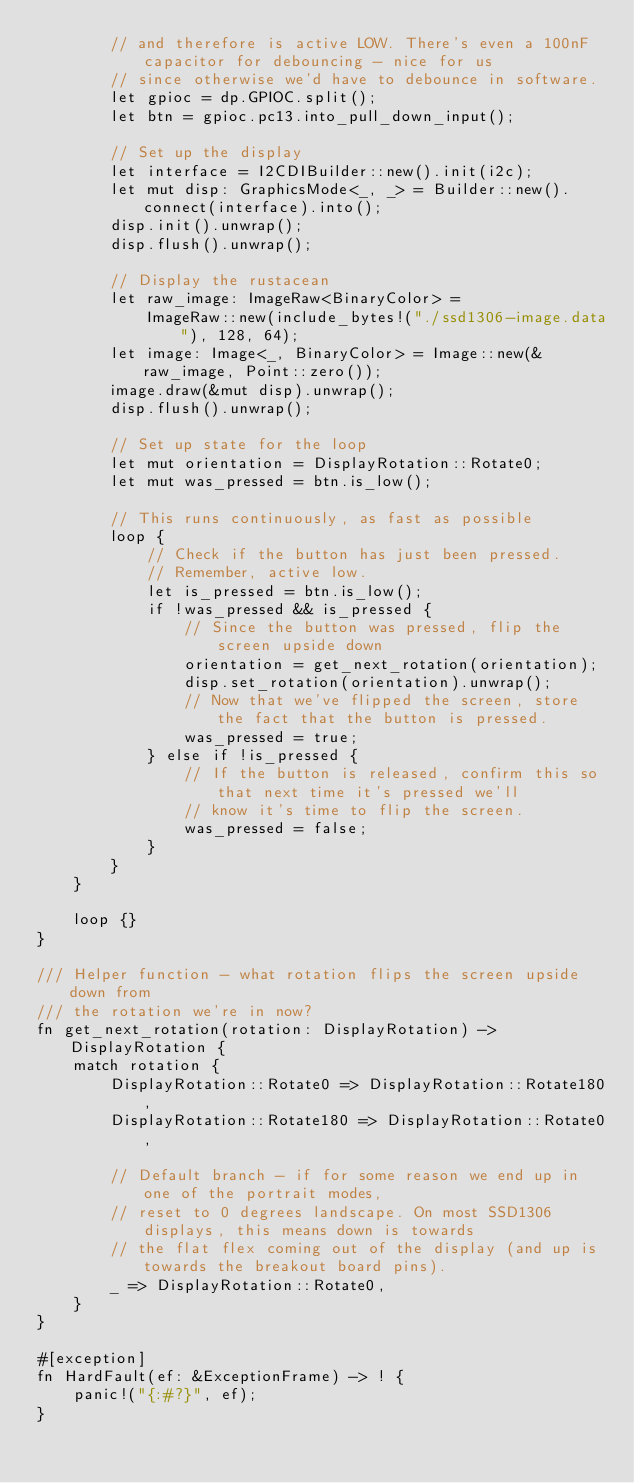<code> <loc_0><loc_0><loc_500><loc_500><_Rust_>        // and therefore is active LOW. There's even a 100nF capacitor for debouncing - nice for us
        // since otherwise we'd have to debounce in software.
        let gpioc = dp.GPIOC.split();
        let btn = gpioc.pc13.into_pull_down_input();

        // Set up the display
        let interface = I2CDIBuilder::new().init(i2c);
        let mut disp: GraphicsMode<_, _> = Builder::new().connect(interface).into();
        disp.init().unwrap();
        disp.flush().unwrap();

        // Display the rustacean
        let raw_image: ImageRaw<BinaryColor> =
            ImageRaw::new(include_bytes!("./ssd1306-image.data"), 128, 64);
        let image: Image<_, BinaryColor> = Image::new(&raw_image, Point::zero());
        image.draw(&mut disp).unwrap();
        disp.flush().unwrap();

        // Set up state for the loop
        let mut orientation = DisplayRotation::Rotate0;
        let mut was_pressed = btn.is_low();

        // This runs continuously, as fast as possible
        loop {
            // Check if the button has just been pressed.
            // Remember, active low.
            let is_pressed = btn.is_low();
            if !was_pressed && is_pressed {
                // Since the button was pressed, flip the screen upside down
                orientation = get_next_rotation(orientation);
                disp.set_rotation(orientation).unwrap();
                // Now that we've flipped the screen, store the fact that the button is pressed.
                was_pressed = true;
            } else if !is_pressed {
                // If the button is released, confirm this so that next time it's pressed we'll
                // know it's time to flip the screen.
                was_pressed = false;
            }
        }
    }

    loop {}
}

/// Helper function - what rotation flips the screen upside down from
/// the rotation we're in now?
fn get_next_rotation(rotation: DisplayRotation) -> DisplayRotation {
    match rotation {
        DisplayRotation::Rotate0 => DisplayRotation::Rotate180,
        DisplayRotation::Rotate180 => DisplayRotation::Rotate0,

        // Default branch - if for some reason we end up in one of the portrait modes,
        // reset to 0 degrees landscape. On most SSD1306 displays, this means down is towards
        // the flat flex coming out of the display (and up is towards the breakout board pins).
        _ => DisplayRotation::Rotate0,
    }
}

#[exception]
fn HardFault(ef: &ExceptionFrame) -> ! {
    panic!("{:#?}", ef);
}
</code> 